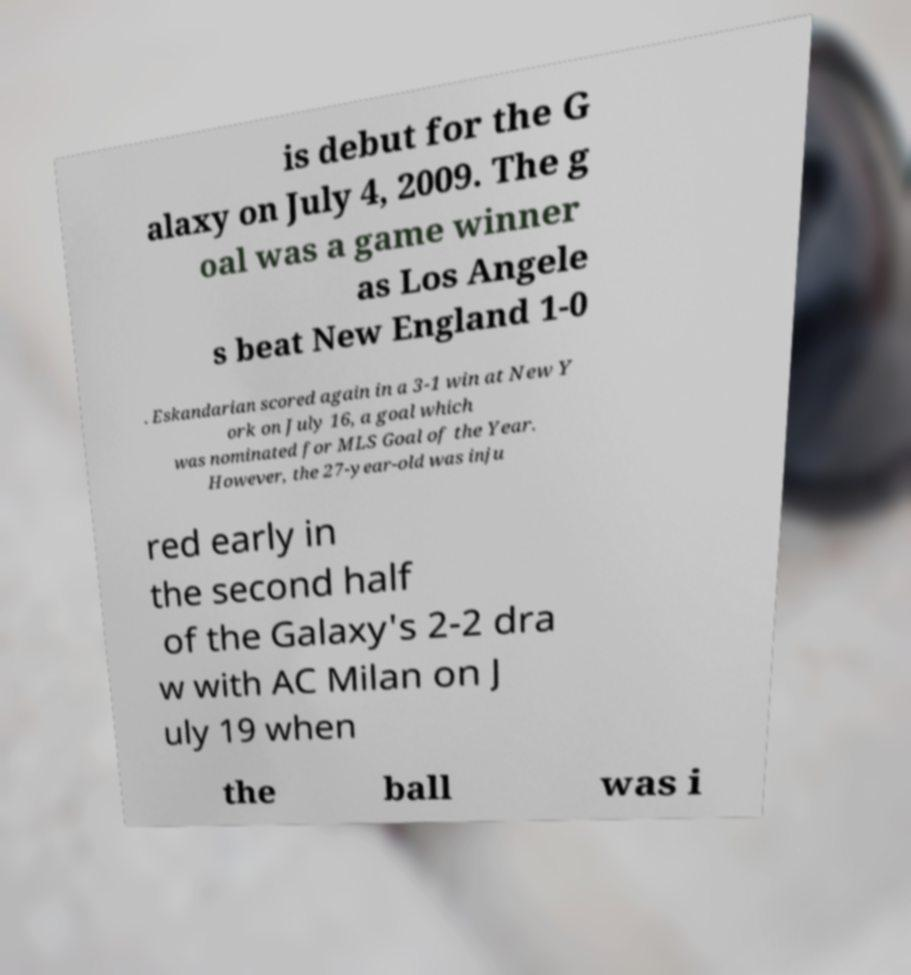What messages or text are displayed in this image? I need them in a readable, typed format. is debut for the G alaxy on July 4, 2009. The g oal was a game winner as Los Angele s beat New England 1-0 . Eskandarian scored again in a 3-1 win at New Y ork on July 16, a goal which was nominated for MLS Goal of the Year. However, the 27-year-old was inju red early in the second half of the Galaxy's 2-2 dra w with AC Milan on J uly 19 when the ball was i 